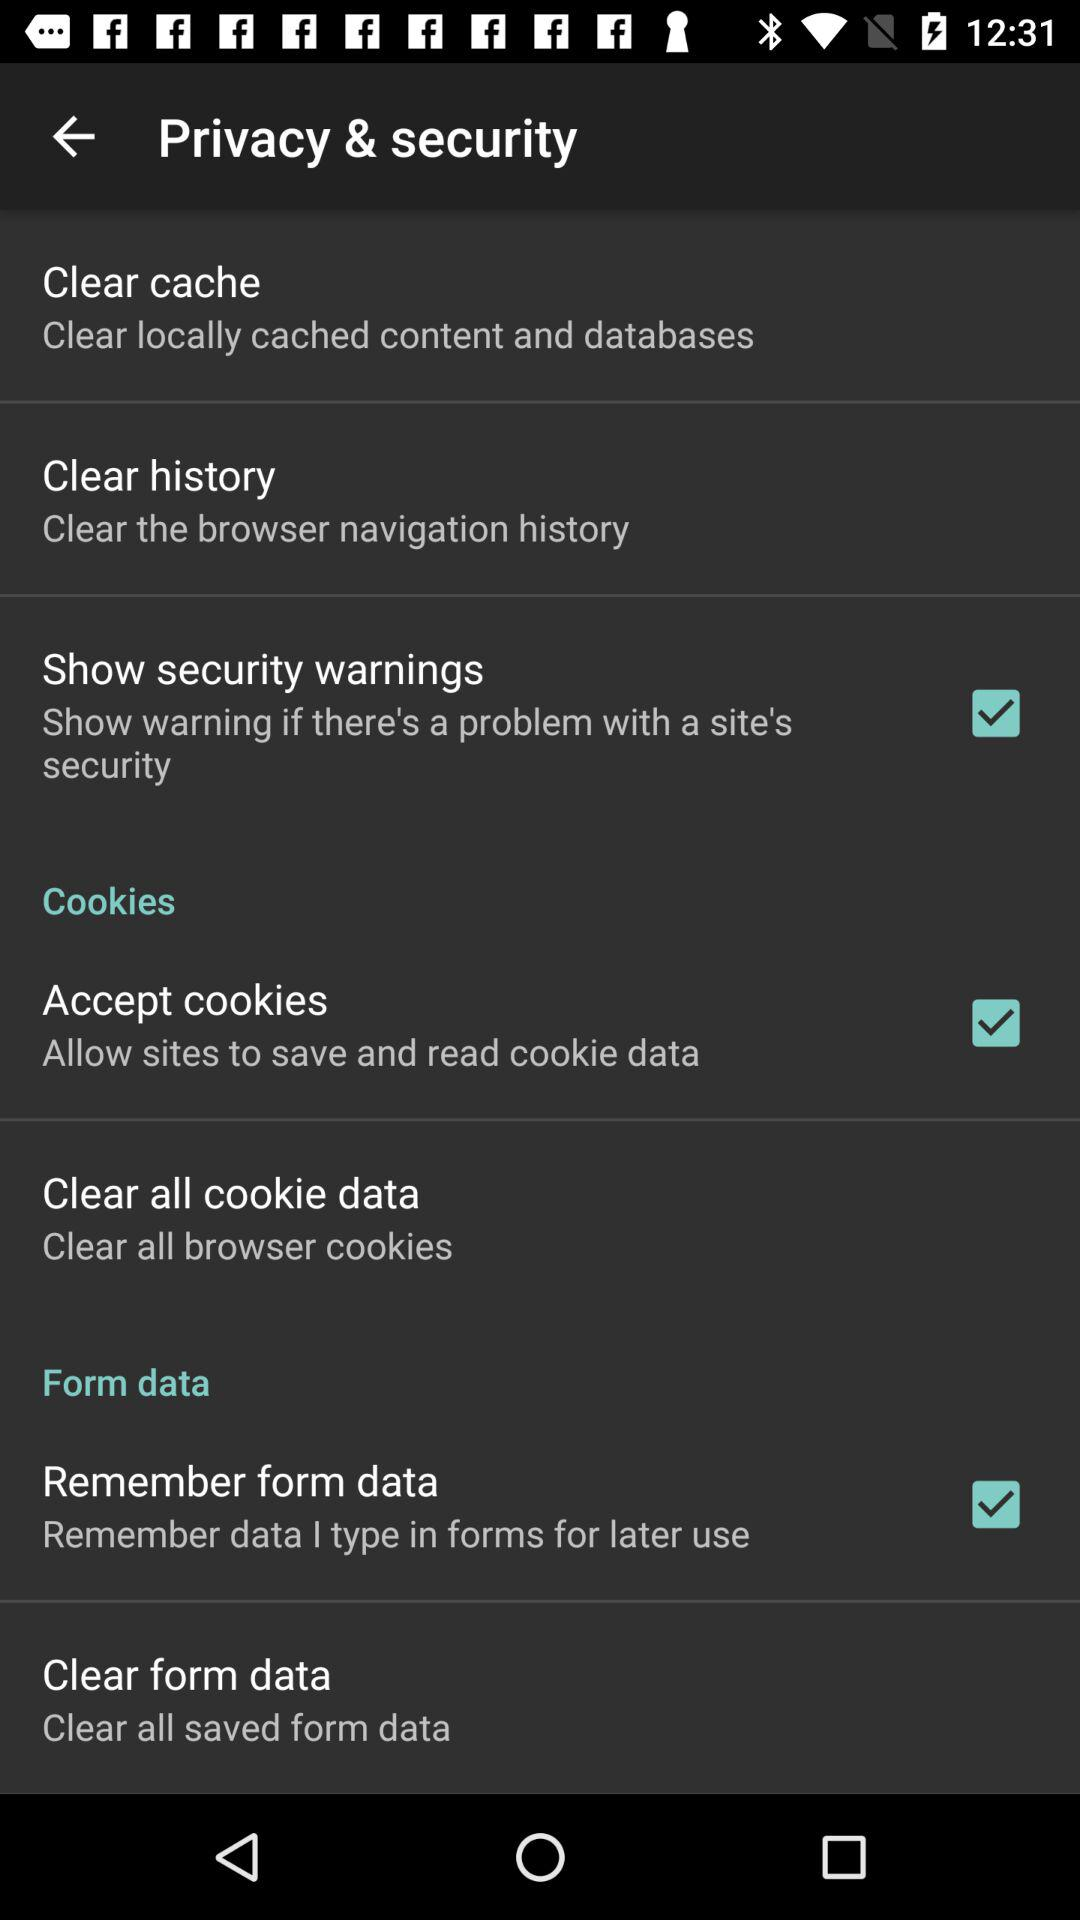What is the description of "Clear all cookie data"? The description of "Clear all cookie data" is "Clear all browser cookies". 